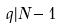<formula> <loc_0><loc_0><loc_500><loc_500>q | N - 1</formula> 